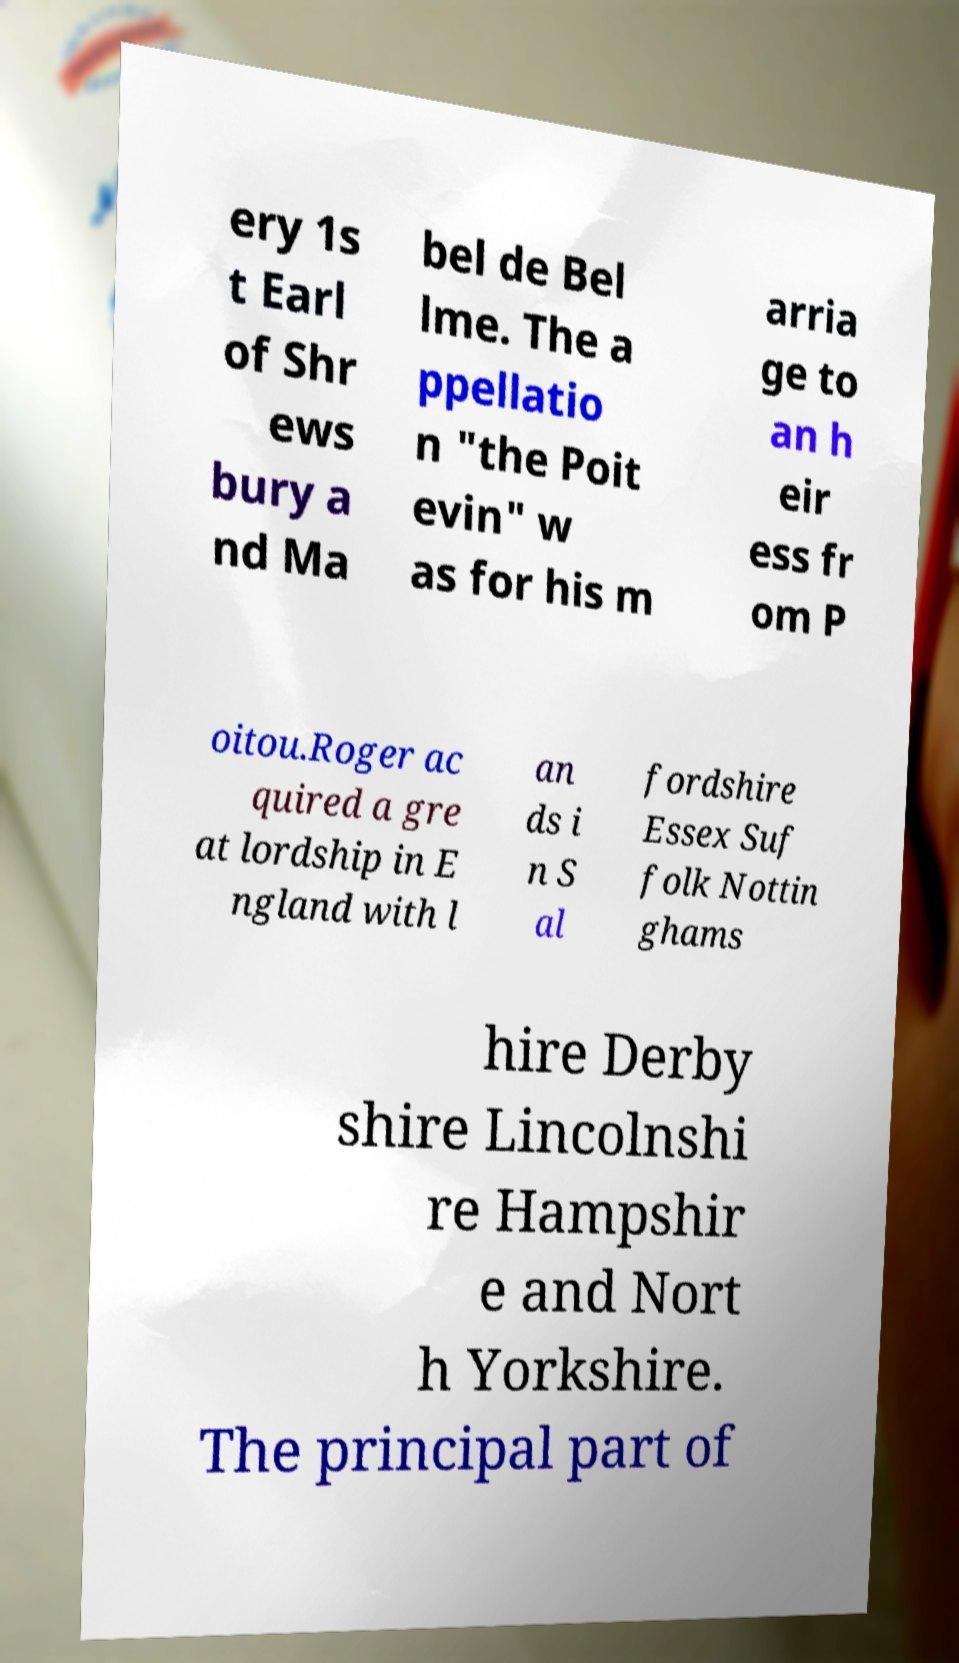What messages or text are displayed in this image? I need them in a readable, typed format. ery 1s t Earl of Shr ews bury a nd Ma bel de Bel lme. The a ppellatio n "the Poit evin" w as for his m arria ge to an h eir ess fr om P oitou.Roger ac quired a gre at lordship in E ngland with l an ds i n S al fordshire Essex Suf folk Nottin ghams hire Derby shire Lincolnshi re Hampshir e and Nort h Yorkshire. The principal part of 